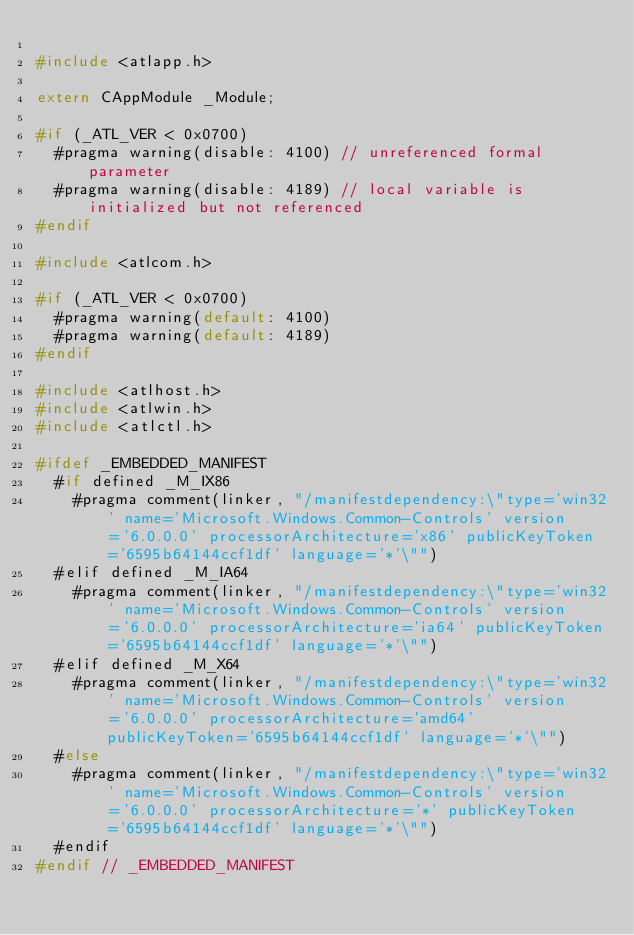Convert code to text. <code><loc_0><loc_0><loc_500><loc_500><_C_>
#include <atlapp.h>

extern CAppModule _Module;

#if (_ATL_VER < 0x0700)
  #pragma warning(disable: 4100) // unreferenced formal parameter
  #pragma warning(disable: 4189) // local variable is initialized but not referenced
#endif

#include <atlcom.h>

#if (_ATL_VER < 0x0700)
  #pragma warning(default: 4100)
  #pragma warning(default: 4189)
#endif

#include <atlhost.h>
#include <atlwin.h>
#include <atlctl.h>

#ifdef _EMBEDDED_MANIFEST
  #if defined _M_IX86
    #pragma comment(linker, "/manifestdependency:\"type='win32' name='Microsoft.Windows.Common-Controls' version='6.0.0.0' processorArchitecture='x86' publicKeyToken='6595b64144ccf1df' language='*'\"")
  #elif defined _M_IA64
    #pragma comment(linker, "/manifestdependency:\"type='win32' name='Microsoft.Windows.Common-Controls' version='6.0.0.0' processorArchitecture='ia64' publicKeyToken='6595b64144ccf1df' language='*'\"")
  #elif defined _M_X64
    #pragma comment(linker, "/manifestdependency:\"type='win32' name='Microsoft.Windows.Common-Controls' version='6.0.0.0' processorArchitecture='amd64' publicKeyToken='6595b64144ccf1df' language='*'\"")
  #else
    #pragma comment(linker, "/manifestdependency:\"type='win32' name='Microsoft.Windows.Common-Controls' version='6.0.0.0' processorArchitecture='*' publicKeyToken='6595b64144ccf1df' language='*'\"")
  #endif
#endif // _EMBEDDED_MANIFEST
</code> 